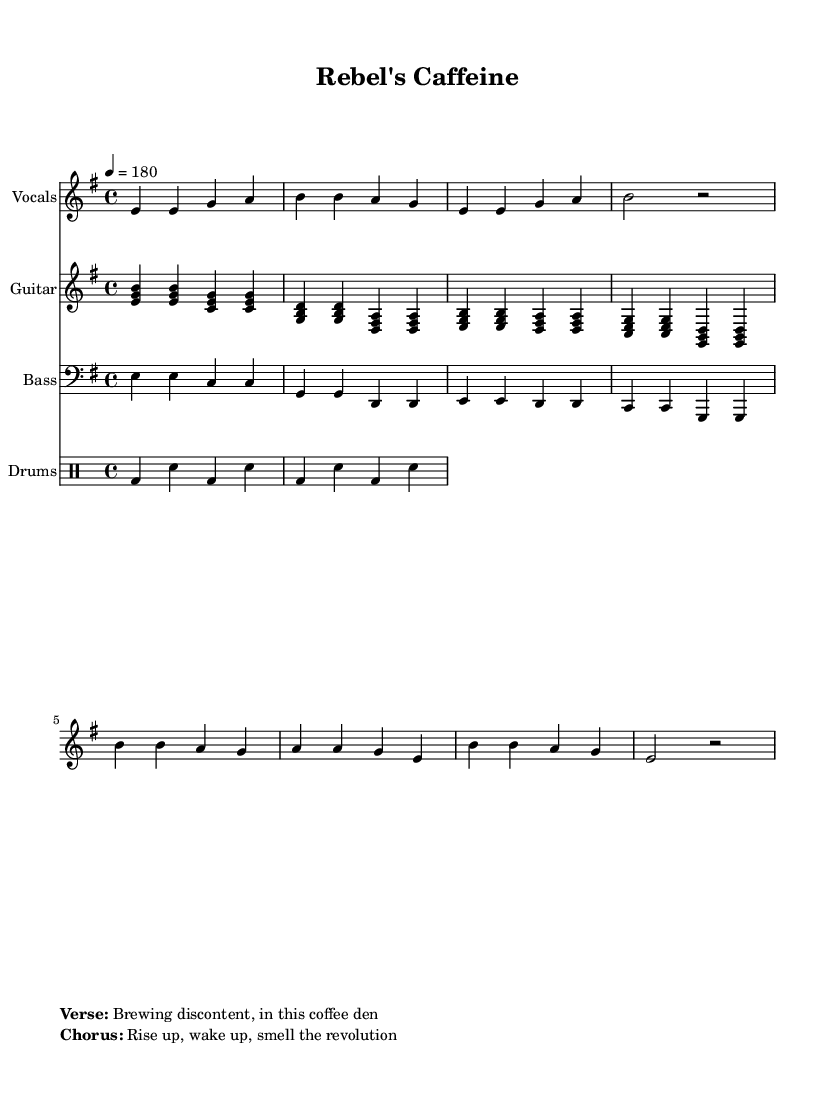What is the key signature of this music? The key signature can be found at the beginning of the score. Here, it shows that there are no sharps or flats, which indicates it is in E minor (one sharp in the relative major).
Answer: E minor What is the time signature of this music? The time signature is indicated at the beginning of the score, showing "4/4," which means there are four beats in each measure.
Answer: 4/4 What is the tempo of this music? The tempo is specified at the start of the score as "4 = 180," indicating that the quarter note should be played at a speed of 180 beats per minute.
Answer: 180 How many measures are in the verse section? By analyzing the vocal line, the verse consists of two repeated sequences of measures, totaling 4 measures in the verse.
Answer: 4 What chords are used in the chorus? By examining the guitar line presented in the score, the chords in the chorus are E minor, D, and C.
Answer: E minor, D, C What is the lyrical theme of this piece? The lyrics provided suggest themes of discontent and revolution, common in politically charged punk music. This is indicated through the phrases in the markup.
Answer: Discontent, revolution How does the bass line relate to the guitar chords? The bass line usually supports the guitar chords by outlining the root notes of the chords played in the guitar line; in this music, it follows the E, G, C, and D that are present in the guitar section.
Answer: Root notes support 